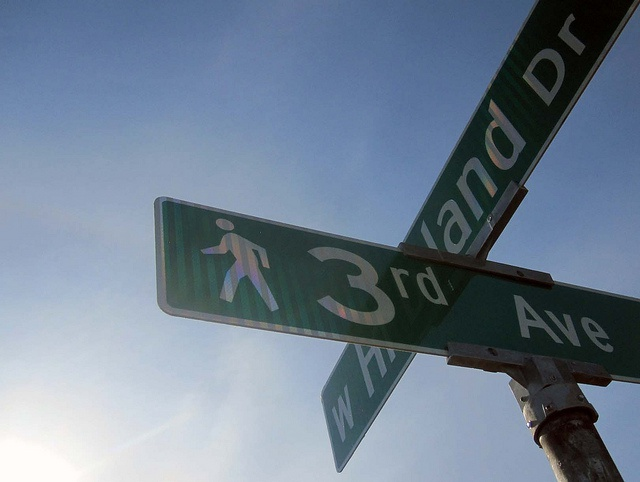Describe the objects in this image and their specific colors. I can see various objects in this image with different colors. 